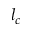<formula> <loc_0><loc_0><loc_500><loc_500>l _ { c }</formula> 